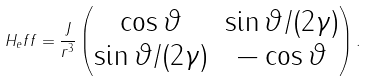Convert formula to latex. <formula><loc_0><loc_0><loc_500><loc_500>H _ { e } f f = \frac { J } { r ^ { 3 } } \begin{pmatrix} \cos \vartheta & \sin \vartheta / ( 2 \gamma ) \\ \sin \vartheta / ( 2 \gamma ) & - \cos \vartheta \end{pmatrix} .</formula> 